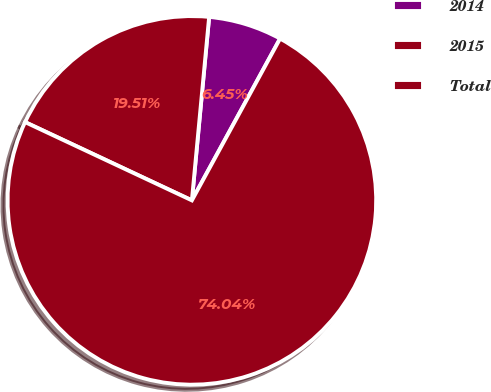Convert chart to OTSL. <chart><loc_0><loc_0><loc_500><loc_500><pie_chart><fcel>2014<fcel>2015<fcel>Total<nl><fcel>6.45%<fcel>19.51%<fcel>74.04%<nl></chart> 